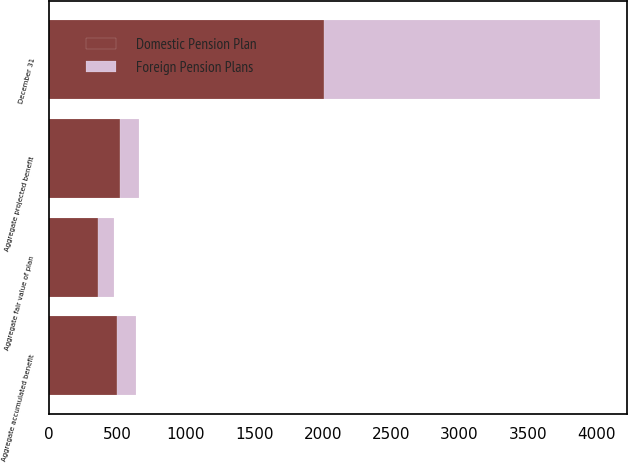<chart> <loc_0><loc_0><loc_500><loc_500><stacked_bar_chart><ecel><fcel>December 31<fcel>Aggregate projected benefit<fcel>Aggregate accumulated benefit<fcel>Aggregate fair value of plan<nl><fcel>Foreign Pension Plans<fcel>2012<fcel>140.6<fcel>140.6<fcel>115.7<nl><fcel>Domestic Pension Plan<fcel>2012<fcel>515.8<fcel>497.3<fcel>358.5<nl></chart> 